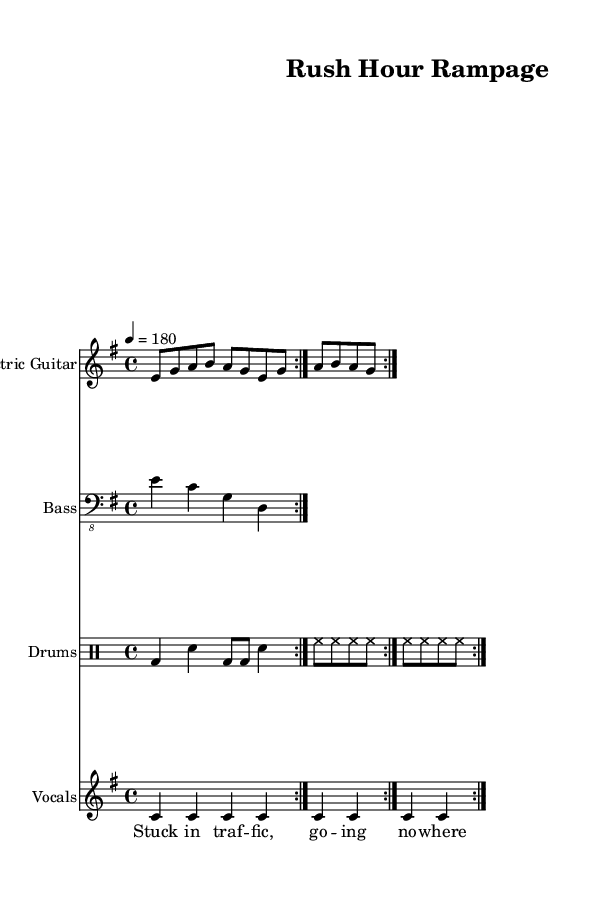What is the key signature of this music? The key signature is indicated in the global section of the sheet music where it specifies E minor. E minor has one sharp (F#).
Answer: E minor What is the time signature of this piece? The time signature is found in the global section, where it states "4/4". This means there are four beats in a measure.
Answer: 4/4 What is the tempo marking of the song? The tempo is specified in the global section as "4 = 180", which means there are 180 beats per minute.
Answer: 180 How many times is the electric guitar riff repeated? In the electric guitar part, the instruction “\repeat volta 2” indicates that the riff is played twice.
Answer: 2 What kind of arrangement is this song? The score includes different music staff types: electric guitar, bass, drums, and vocals, which creates a typical band arrangement for punk music.
Answer: Band arrangement How many beats per measure are indicated for the drums? The drum patterns follow the 4/4 time signature, and each measure consists of four beats. The patterns in the drum section are designed around this.
Answer: 4 